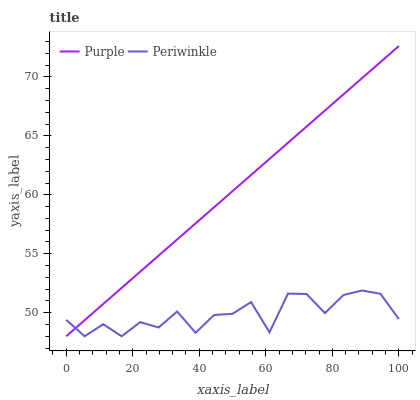Does Periwinkle have the minimum area under the curve?
Answer yes or no. Yes. Does Purple have the maximum area under the curve?
Answer yes or no. Yes. Does Periwinkle have the maximum area under the curve?
Answer yes or no. No. Is Purple the smoothest?
Answer yes or no. Yes. Is Periwinkle the roughest?
Answer yes or no. Yes. Is Periwinkle the smoothest?
Answer yes or no. No. Does Purple have the lowest value?
Answer yes or no. Yes. Does Purple have the highest value?
Answer yes or no. Yes. Does Periwinkle have the highest value?
Answer yes or no. No. Does Periwinkle intersect Purple?
Answer yes or no. Yes. Is Periwinkle less than Purple?
Answer yes or no. No. Is Periwinkle greater than Purple?
Answer yes or no. No. 